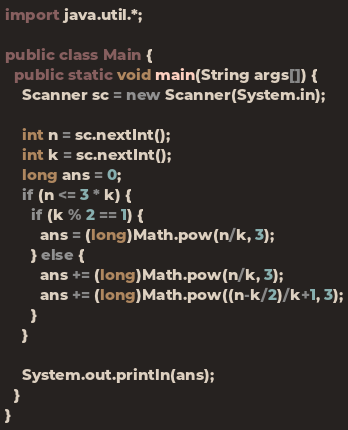<code> <loc_0><loc_0><loc_500><loc_500><_Java_>import java.util.*;

public class Main {
  public static void main(String args[]) {
    Scanner sc = new Scanner(System.in);

    int n = sc.nextInt();
    int k = sc.nextInt();
    long ans = 0;
    if (n <= 3 * k) {
      if (k % 2 == 1) {
        ans = (long)Math.pow(n/k, 3);
      } else {
        ans += (long)Math.pow(n/k, 3);
        ans += (long)Math.pow((n-k/2)/k+1, 3);
      }
    }

    System.out.println(ans);
  }
}
</code> 